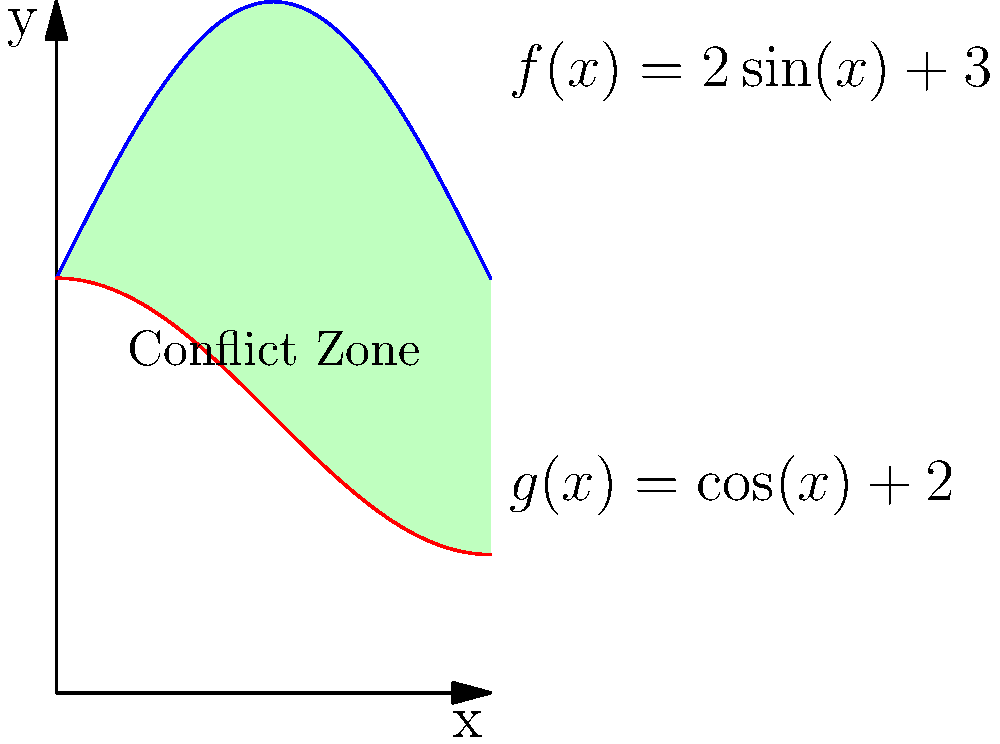As an international security analyst, you're tasked with estimating the total area affected by a conflict in a region with irregular boundaries. The map of the conflict zone can be modeled by the area between two curves: $f(x)=2\sin(x)+3$ and $g(x)=\cos(x)+2$, where $x$ is measured in radians from 0 to $\pi$. Calculate the total area affected by the conflict using integral calculus. Express your answer in square units, rounded to two decimal places. To find the area between two curves, we need to:

1. Identify the upper and lower functions:
   Upper function: $f(x)=2\sin(x)+3$
   Lower function: $g(x)=\cos(x)+2$

2. Set up the integral:
   Area = $\int_{0}^{\pi} [f(x) - g(x)] dx$

3. Substitute the functions:
   Area = $\int_{0}^{\pi} [(2\sin(x)+3) - (\cos(x)+2)] dx$
        = $\int_{0}^{\pi} [2\sin(x) - \cos(x) + 1] dx$

4. Integrate:
   Area = $[-2\cos(x) - \sin(x) + x]_{0}^{\pi}$

5. Evaluate the definite integral:
   Area = $[-2\cos(\pi) - \sin(\pi) + \pi] - [-2\cos(0) - \sin(0) + 0]$
        = $[2 - 0 + \pi] - [-2 - 0 + 0]$
        = $(2 + \pi) - (-2)$
        = $2 + \pi + 2$
        = $\pi + 4$

6. Round to two decimal places:
   Area ≈ 7.14 square units

This calculation provides an estimate of the total area affected by the conflict, based on the given map model.
Answer: 7.14 square units 